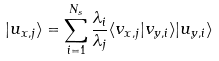Convert formula to latex. <formula><loc_0><loc_0><loc_500><loc_500>| u _ { x , j } \rangle = \sum _ { i = 1 } ^ { N _ { s } } { \frac { \lambda _ { i } } { \lambda _ { j } } \langle v _ { x , j } | v _ { y , i } \rangle | u _ { y , i } \rangle }</formula> 